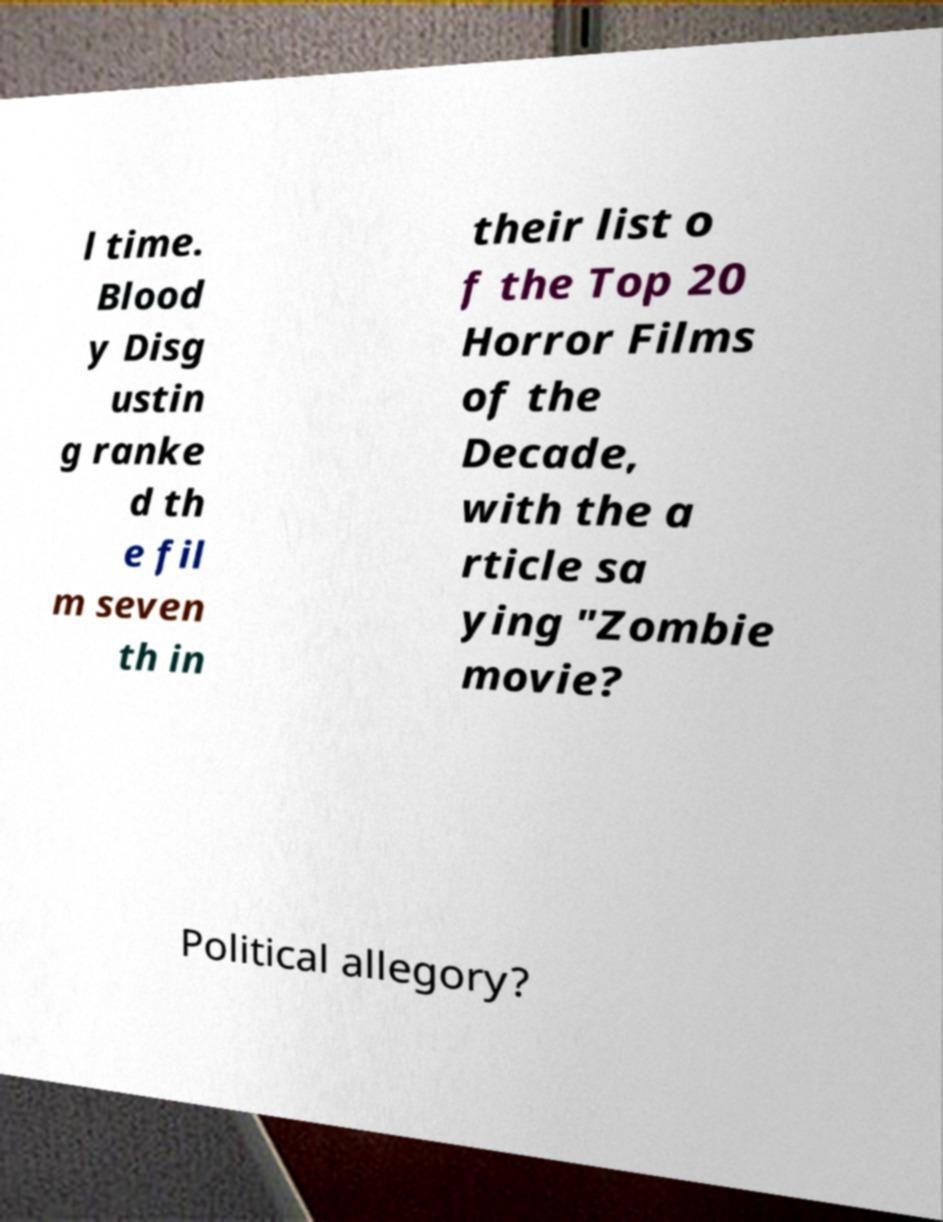I need the written content from this picture converted into text. Can you do that? l time. Blood y Disg ustin g ranke d th e fil m seven th in their list o f the Top 20 Horror Films of the Decade, with the a rticle sa ying "Zombie movie? Political allegory? 